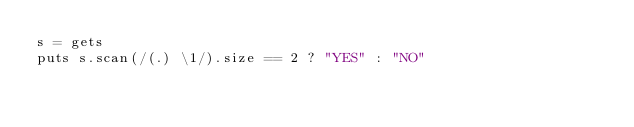<code> <loc_0><loc_0><loc_500><loc_500><_Ruby_>s = gets
puts s.scan(/(.) \1/).size == 2 ? "YES" : "NO"</code> 